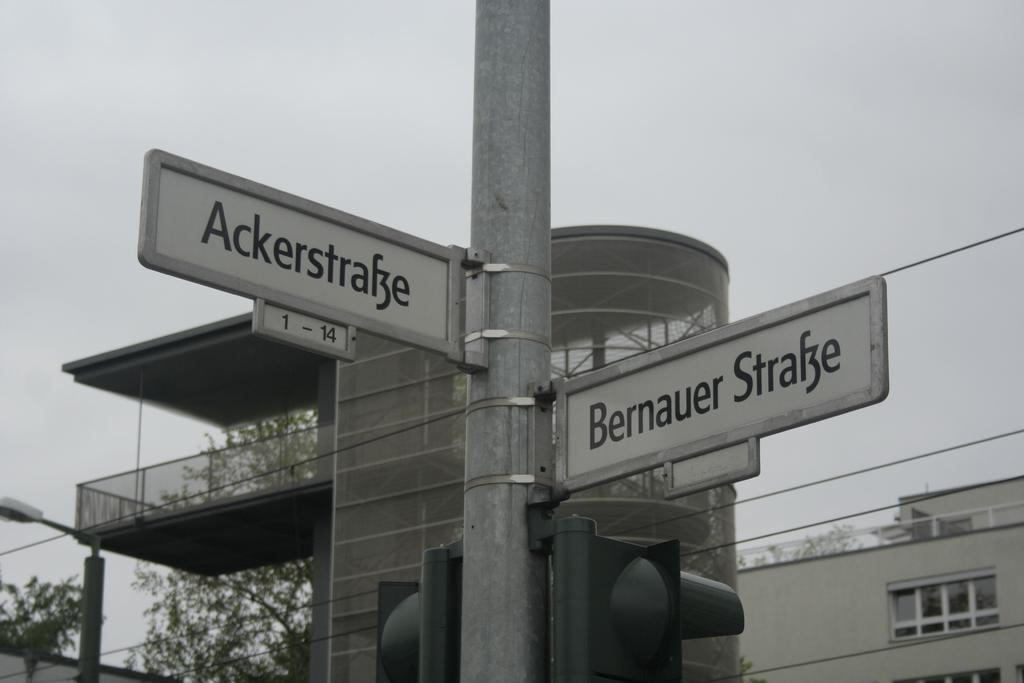Provide a one-sentence caption for the provided image. the street name outside which is Bernaur strake. 